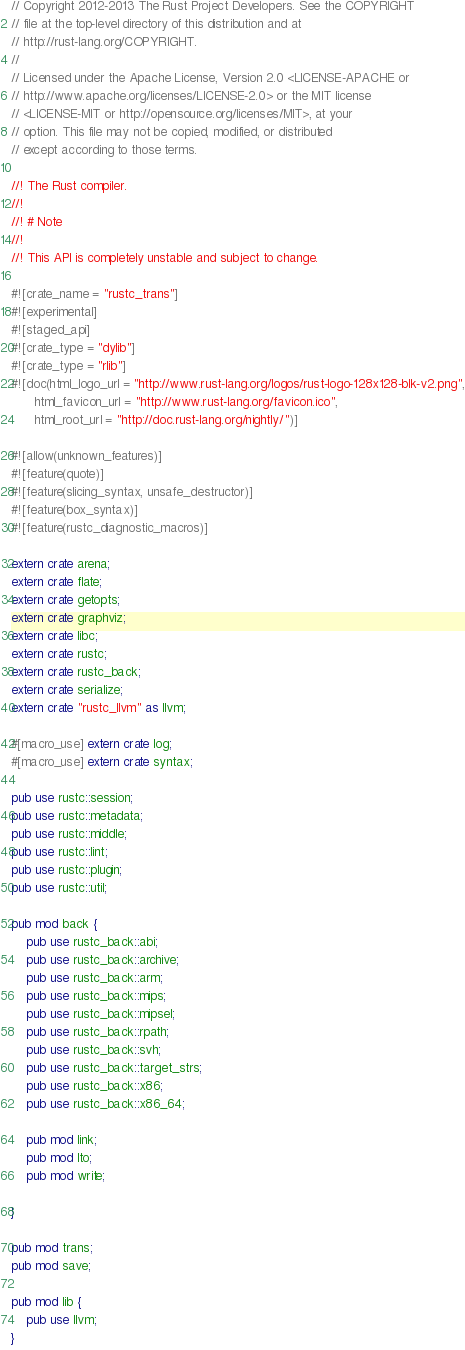Convert code to text. <code><loc_0><loc_0><loc_500><loc_500><_Rust_>// Copyright 2012-2013 The Rust Project Developers. See the COPYRIGHT
// file at the top-level directory of this distribution and at
// http://rust-lang.org/COPYRIGHT.
//
// Licensed under the Apache License, Version 2.0 <LICENSE-APACHE or
// http://www.apache.org/licenses/LICENSE-2.0> or the MIT license
// <LICENSE-MIT or http://opensource.org/licenses/MIT>, at your
// option. This file may not be copied, modified, or distributed
// except according to those terms.

//! The Rust compiler.
//!
//! # Note
//!
//! This API is completely unstable and subject to change.

#![crate_name = "rustc_trans"]
#![experimental]
#![staged_api]
#![crate_type = "dylib"]
#![crate_type = "rlib"]
#![doc(html_logo_url = "http://www.rust-lang.org/logos/rust-logo-128x128-blk-v2.png",
      html_favicon_url = "http://www.rust-lang.org/favicon.ico",
      html_root_url = "http://doc.rust-lang.org/nightly/")]

#![allow(unknown_features)]
#![feature(quote)]
#![feature(slicing_syntax, unsafe_destructor)]
#![feature(box_syntax)]
#![feature(rustc_diagnostic_macros)]

extern crate arena;
extern crate flate;
extern crate getopts;
extern crate graphviz;
extern crate libc;
extern crate rustc;
extern crate rustc_back;
extern crate serialize;
extern crate "rustc_llvm" as llvm;

#[macro_use] extern crate log;
#[macro_use] extern crate syntax;

pub use rustc::session;
pub use rustc::metadata;
pub use rustc::middle;
pub use rustc::lint;
pub use rustc::plugin;
pub use rustc::util;

pub mod back {
    pub use rustc_back::abi;
    pub use rustc_back::archive;
    pub use rustc_back::arm;
    pub use rustc_back::mips;
    pub use rustc_back::mipsel;
    pub use rustc_back::rpath;
    pub use rustc_back::svh;
    pub use rustc_back::target_strs;
    pub use rustc_back::x86;
    pub use rustc_back::x86_64;

    pub mod link;
    pub mod lto;
    pub mod write;

}

pub mod trans;
pub mod save;

pub mod lib {
    pub use llvm;
}
</code> 